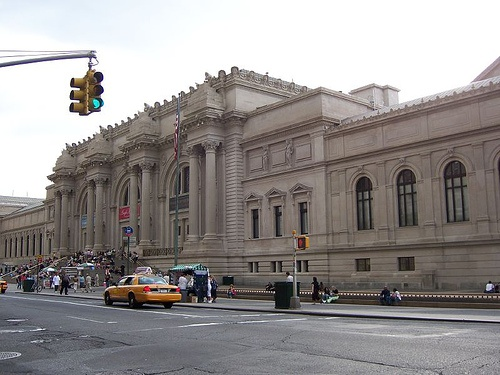Describe the objects in this image and their specific colors. I can see car in white, black, brown, and maroon tones, traffic light in white, olive, and black tones, traffic light in white, black, gray, and maroon tones, people in white, gray, black, darkgray, and lavender tones, and people in white, black, and gray tones in this image. 